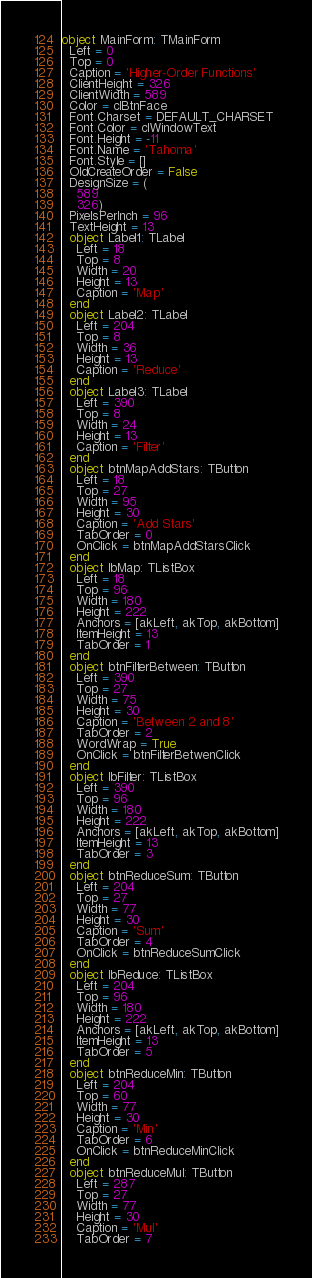Convert code to text. <code><loc_0><loc_0><loc_500><loc_500><_Pascal_>object MainForm: TMainForm
  Left = 0
  Top = 0
  Caption = 'Higher-Order Functions'
  ClientHeight = 326
  ClientWidth = 589
  Color = clBtnFace
  Font.Charset = DEFAULT_CHARSET
  Font.Color = clWindowText
  Font.Height = -11
  Font.Name = 'Tahoma'
  Font.Style = []
  OldCreateOrder = False
  DesignSize = (
    589
    326)
  PixelsPerInch = 96
  TextHeight = 13
  object Label1: TLabel
    Left = 18
    Top = 8
    Width = 20
    Height = 13
    Caption = 'Map'
  end
  object Label2: TLabel
    Left = 204
    Top = 8
    Width = 36
    Height = 13
    Caption = 'Reduce'
  end
  object Label3: TLabel
    Left = 390
    Top = 8
    Width = 24
    Height = 13
    Caption = 'Filter'
  end
  object btnMapAddStars: TButton
    Left = 18
    Top = 27
    Width = 95
    Height = 30
    Caption = 'Add Stars'
    TabOrder = 0
    OnClick = btnMapAddStarsClick
  end
  object lbMap: TListBox
    Left = 18
    Top = 96
    Width = 180
    Height = 222
    Anchors = [akLeft, akTop, akBottom]
    ItemHeight = 13
    TabOrder = 1
  end
  object btnFilterBetween: TButton
    Left = 390
    Top = 27
    Width = 75
    Height = 30
    Caption = 'Between 2 and 8'
    TabOrder = 2
    WordWrap = True
    OnClick = btnFilterBetwenClick
  end
  object lbFilter: TListBox
    Left = 390
    Top = 96
    Width = 180
    Height = 222
    Anchors = [akLeft, akTop, akBottom]
    ItemHeight = 13
    TabOrder = 3
  end
  object btnReduceSum: TButton
    Left = 204
    Top = 27
    Width = 77
    Height = 30
    Caption = 'Sum'
    TabOrder = 4
    OnClick = btnReduceSumClick
  end
  object lbReduce: TListBox
    Left = 204
    Top = 96
    Width = 180
    Height = 222
    Anchors = [akLeft, akTop, akBottom]
    ItemHeight = 13
    TabOrder = 5
  end
  object btnReduceMin: TButton
    Left = 204
    Top = 60
    Width = 77
    Height = 30
    Caption = 'Min'
    TabOrder = 6
    OnClick = btnReduceMinClick
  end
  object btnReduceMul: TButton
    Left = 287
    Top = 27
    Width = 77
    Height = 30
    Caption = 'Mul'
    TabOrder = 7</code> 